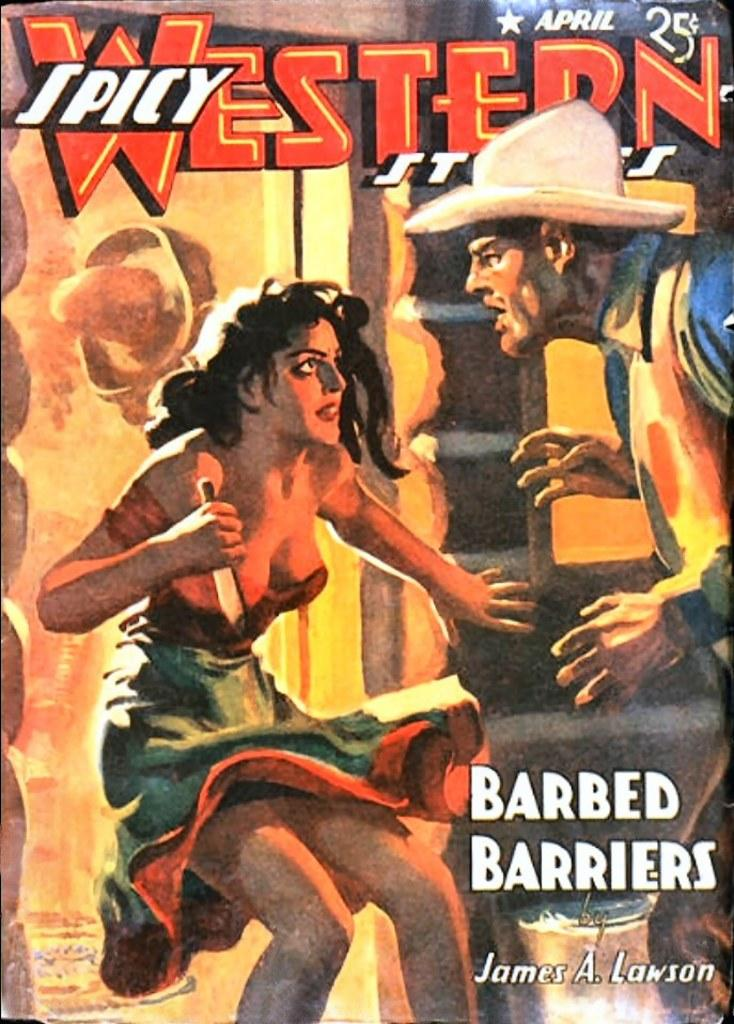What is depicted on the cover page of the book in the image? The cover page of the book contains a woman holding a knife and a man. What is the woman holding on the cover page? The woman is holding a knife on the cover page. Can you describe the man on the cover page? There is a man on the cover page, but no specific details about his appearance are provided. What else can be seen on the cover page besides the people? There is text written on the cover page. How many pets are visible on the cover page of the book? There are no pets visible on the cover page of the book. What season is depicted on the cover page of the book? The cover page of the book does not depict a specific season, such as spring. 